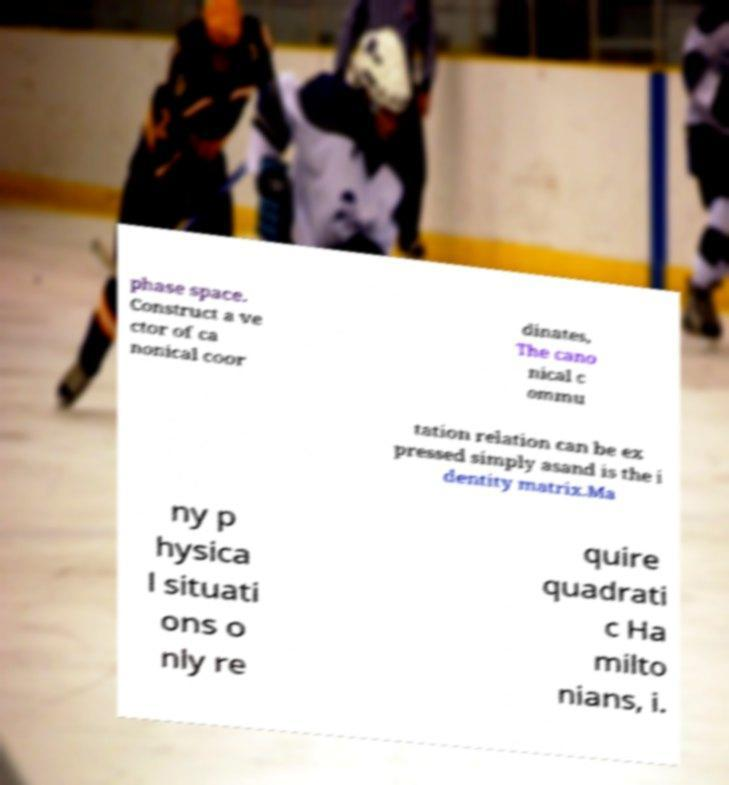Please read and relay the text visible in this image. What does it say? phase space. Construct a ve ctor of ca nonical coor dinates, The cano nical c ommu tation relation can be ex pressed simply asand is the i dentity matrix.Ma ny p hysica l situati ons o nly re quire quadrati c Ha milto nians, i. 